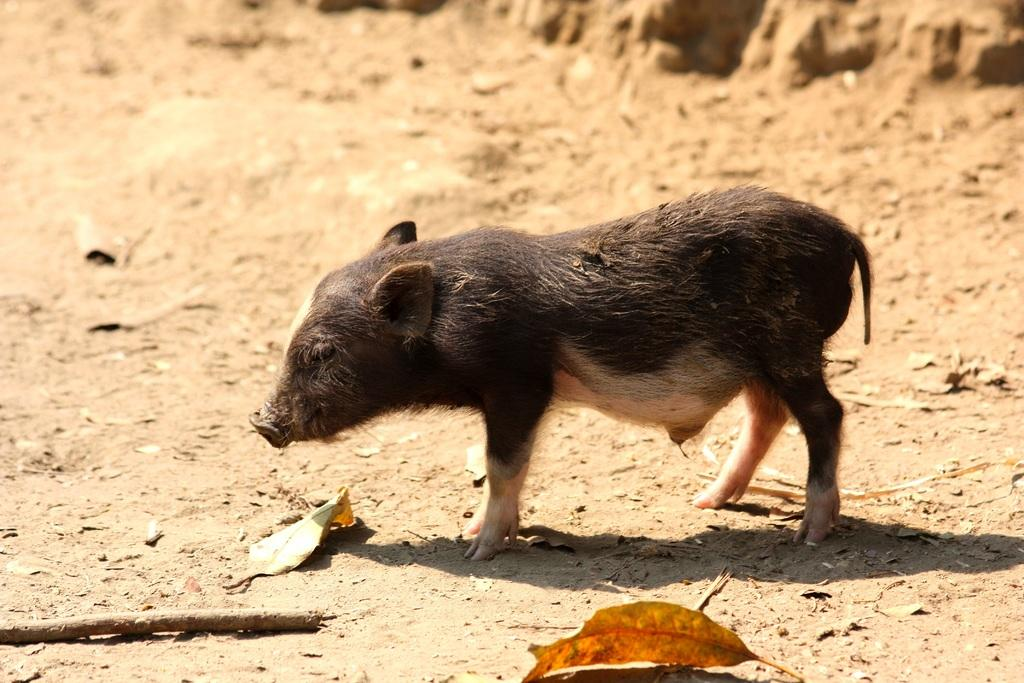What is the main subject in the center of the image? There is a pig in the center of the image. In which direction is the pig facing? The pig is facing towards the left. What objects can be seen at the bottom of the image? There is a stick and a leaf at the bottom of the image. What advice is the beggar giving to the pig in the image? There is no beggar present in the image, and therefore no such interaction can be observed. 